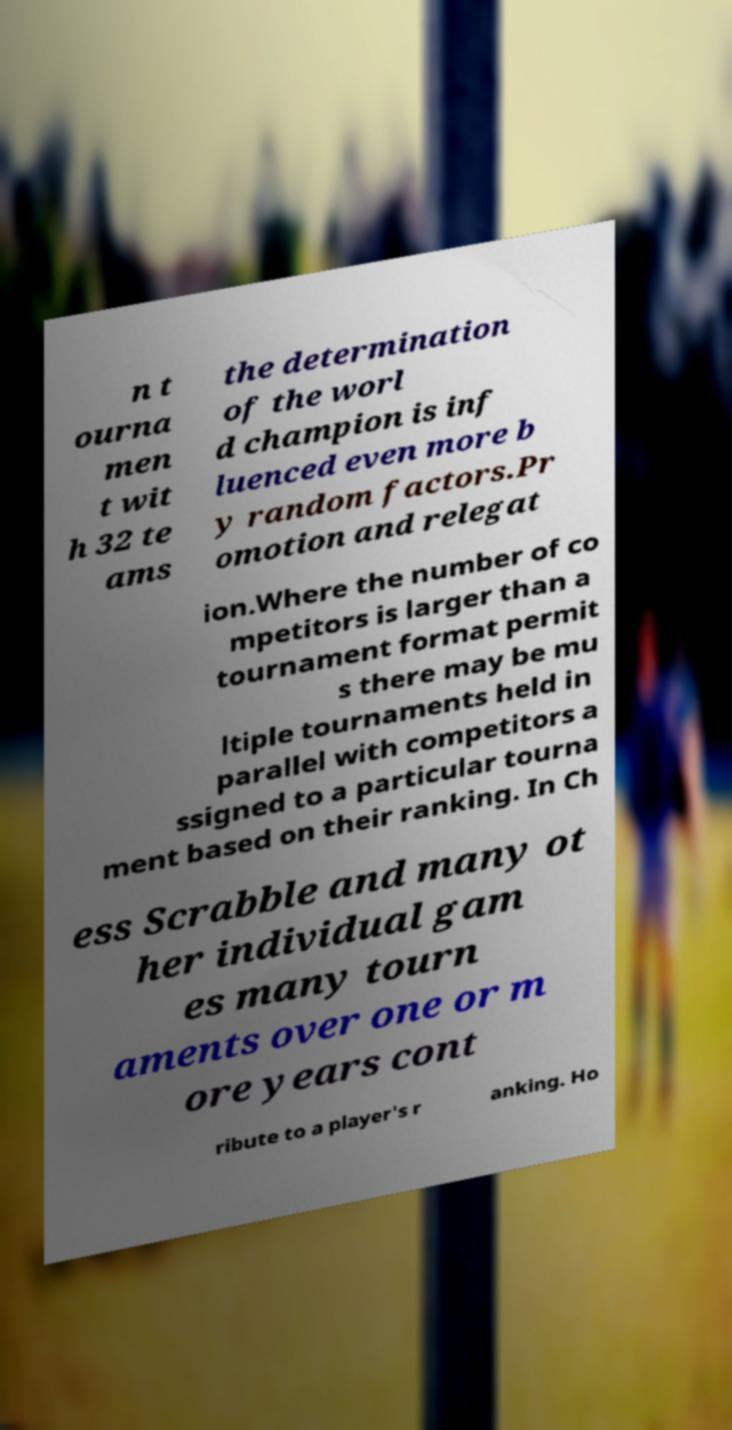Please read and relay the text visible in this image. What does it say? n t ourna men t wit h 32 te ams the determination of the worl d champion is inf luenced even more b y random factors.Pr omotion and relegat ion.Where the number of co mpetitors is larger than a tournament format permit s there may be mu ltiple tournaments held in parallel with competitors a ssigned to a particular tourna ment based on their ranking. In Ch ess Scrabble and many ot her individual gam es many tourn aments over one or m ore years cont ribute to a player's r anking. Ho 